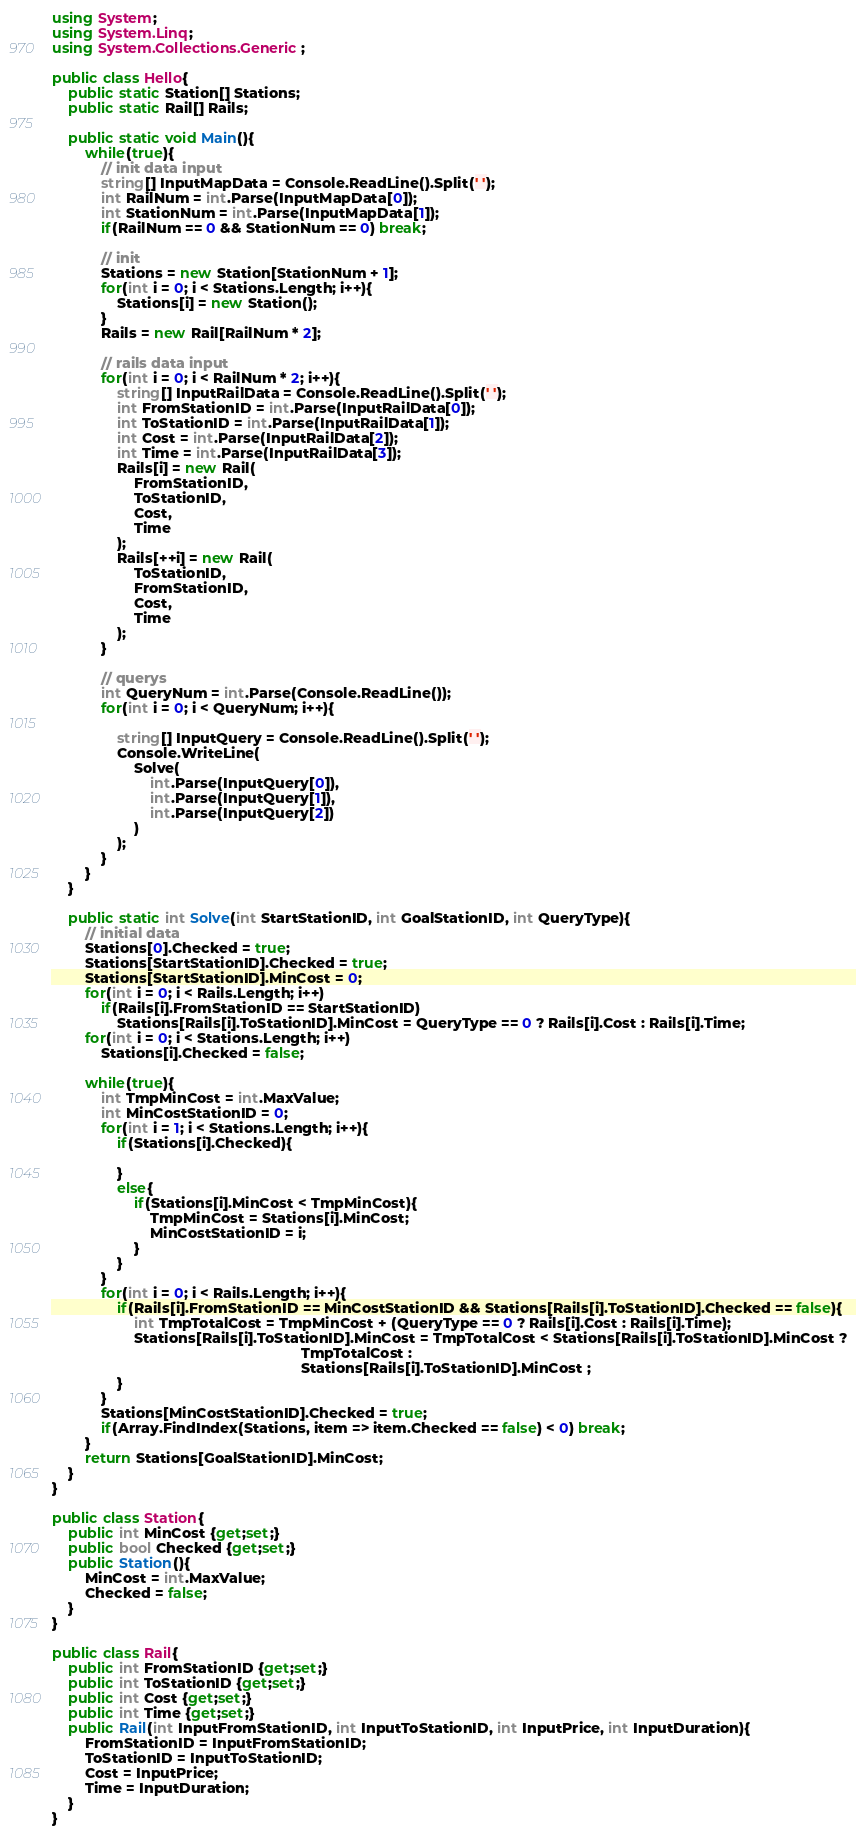Convert code to text. <code><loc_0><loc_0><loc_500><loc_500><_C#_>using System;
using System.Linq;
using System.Collections.Generic;

public class Hello{
    public static Station[] Stations;
    public static Rail[] Rails;
    
    public static void Main(){
        while(true){
            // init data input
            string[] InputMapData = Console.ReadLine().Split(' ');
            int RailNum = int.Parse(InputMapData[0]);
            int StationNum = int.Parse(InputMapData[1]);
            if(RailNum == 0 && StationNum == 0) break;
            
            // init
            Stations = new Station[StationNum + 1];
            for(int i = 0; i < Stations.Length; i++){
                Stations[i] = new Station();
            }
            Rails = new Rail[RailNum * 2];

            // rails data input
            for(int i = 0; i < RailNum * 2; i++){
                string[] InputRailData = Console.ReadLine().Split(' ');
                int FromStationID = int.Parse(InputRailData[0]);
                int ToStationID = int.Parse(InputRailData[1]);
                int Cost = int.Parse(InputRailData[2]);
                int Time = int.Parse(InputRailData[3]);
                Rails[i] = new Rail(
                    FromStationID,
                    ToStationID,
                    Cost,
                    Time
                );
                Rails[++i] = new Rail(
                    ToStationID,
                    FromStationID,
                    Cost,
                    Time
                );
            }

            // querys
            int QueryNum = int.Parse(Console.ReadLine());
            for(int i = 0; i < QueryNum; i++){

                string[] InputQuery = Console.ReadLine().Split(' ');
                Console.WriteLine(
                    Solve(
                        int.Parse(InputQuery[0]),
                        int.Parse(InputQuery[1]),
                        int.Parse(InputQuery[2])
                    )
                );
            }
        }
    }
    
    public static int Solve(int StartStationID, int GoalStationID, int QueryType){
        // initial data
        Stations[0].Checked = true;
        Stations[StartStationID].Checked = true;
        Stations[StartStationID].MinCost = 0;
        for(int i = 0; i < Rails.Length; i++)
            if(Rails[i].FromStationID == StartStationID)
                Stations[Rails[i].ToStationID].MinCost = QueryType == 0 ? Rails[i].Cost : Rails[i].Time;
        for(int i = 0; i < Stations.Length; i++)
            Stations[i].Checked = false;
        
        while(true){
            int TmpMinCost = int.MaxValue;
            int MinCostStationID = 0;
            for(int i = 1; i < Stations.Length; i++){
                if(Stations[i].Checked){
                    
                }
                else{
                    if(Stations[i].MinCost < TmpMinCost){
                        TmpMinCost = Stations[i].MinCost;
                        MinCostStationID = i;
                    }
                }
            }
            for(int i = 0; i < Rails.Length; i++){
                if(Rails[i].FromStationID == MinCostStationID && Stations[Rails[i].ToStationID].Checked == false){
                    int TmpTotalCost = TmpMinCost + (QueryType == 0 ? Rails[i].Cost : Rails[i].Time);
                    Stations[Rails[i].ToStationID].MinCost = TmpTotalCost < Stations[Rails[i].ToStationID].MinCost ?
                                                             TmpTotalCost : 
                                                             Stations[Rails[i].ToStationID].MinCost ;
                }
            }
            Stations[MinCostStationID].Checked = true;
            if(Array.FindIndex(Stations, item => item.Checked == false) < 0) break;
        }
        return Stations[GoalStationID].MinCost;
    }
}

public class Station{
    public int MinCost {get;set;}
    public bool Checked {get;set;}
    public Station(){
        MinCost = int.MaxValue;
        Checked = false;
    }
}

public class Rail{
    public int FromStationID {get;set;}
    public int ToStationID {get;set;}
    public int Cost {get;set;}
    public int Time {get;set;}
    public Rail(int InputFromStationID, int InputToStationID, int InputPrice, int InputDuration){
        FromStationID = InputFromStationID;
        ToStationID = InputToStationID;
        Cost = InputPrice;
        Time = InputDuration;
    }
}</code> 